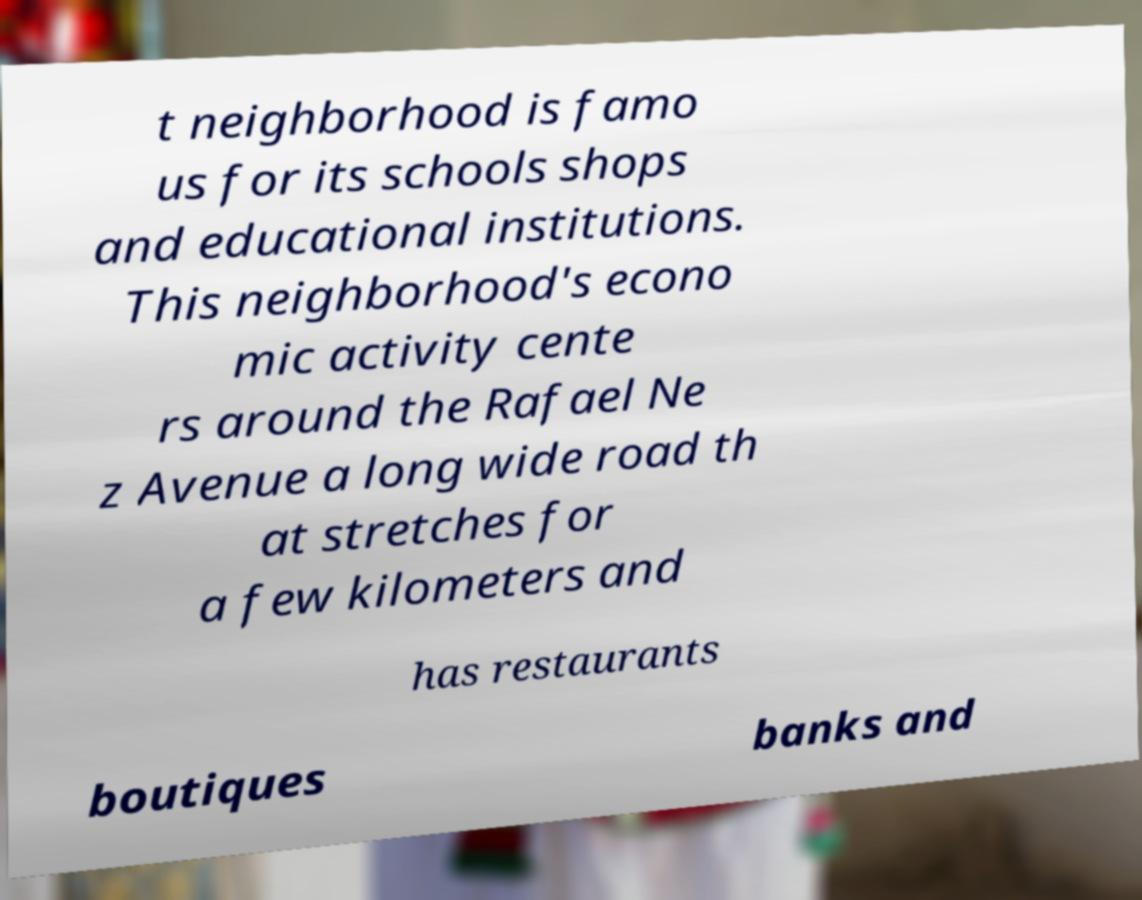Please identify and transcribe the text found in this image. t neighborhood is famo us for its schools shops and educational institutions. This neighborhood's econo mic activity cente rs around the Rafael Ne z Avenue a long wide road th at stretches for a few kilometers and has restaurants boutiques banks and 